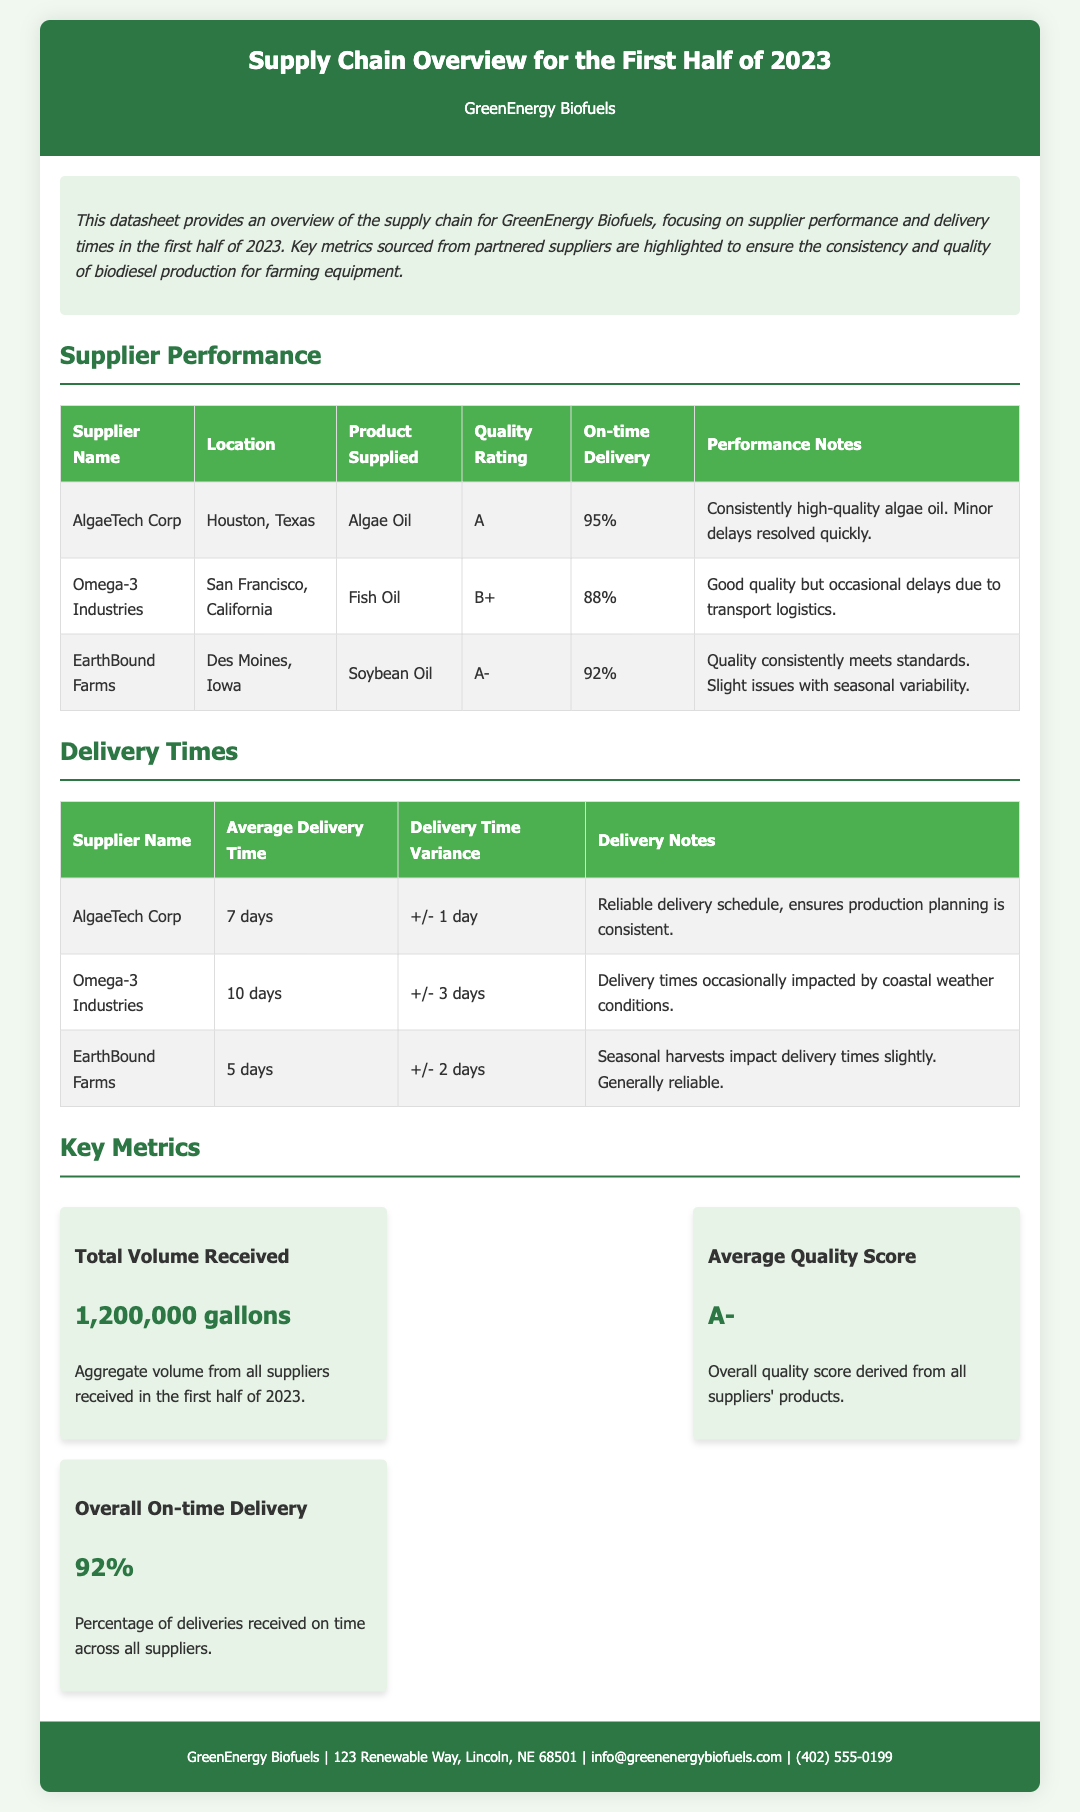What is the average quality score? The average quality score is derived from all suppliers' products, which is A-.
Answer: A- Who is the supplier located in Houston, Texas? The supplier's location is specified in the document as Houston, Texas, which corresponds to AlgaeTech Corp.
Answer: AlgaeTech Corp What percentage of deliveries were on time? The document states that the percentage of deliveries received on time across all suppliers is 92%.
Answer: 92% What is the average delivery time for EarthBound Farms? The average delivery time is noted in the delivery times section and is reported as 5 days.
Answer: 5 days Which supplier has a quality rating of B+? The quality rating of B+ is mentioned next to the supplier name Omega-3 Industries in the supplier performance table.
Answer: Omega-3 Industries What is the total volume received from all suppliers? The total volume received is summarized in the key metrics section, which states it is 1,200,000 gallons.
Answer: 1,200,000 gallons What are the delivery time variances for Omega-3 Industries? The document indicates the delivery time variance listed for Omega-3 Industries is +/- 3 days.
Answer: +/- 3 days What product does EarthBound Farms supply? The product supplied by EarthBound Farms is specified in the supplier performance section as soybean oil.
Answer: Soybean Oil What is the performance note for the supplier with an A quality rating? The performance note for suppliers is reviewed, and AlgaeTech Corp has performance notes indicating consistently high-quality algae oil and minor delays resolved quickly.
Answer: Consistently high-quality algae oil. Minor delays resolved quickly 